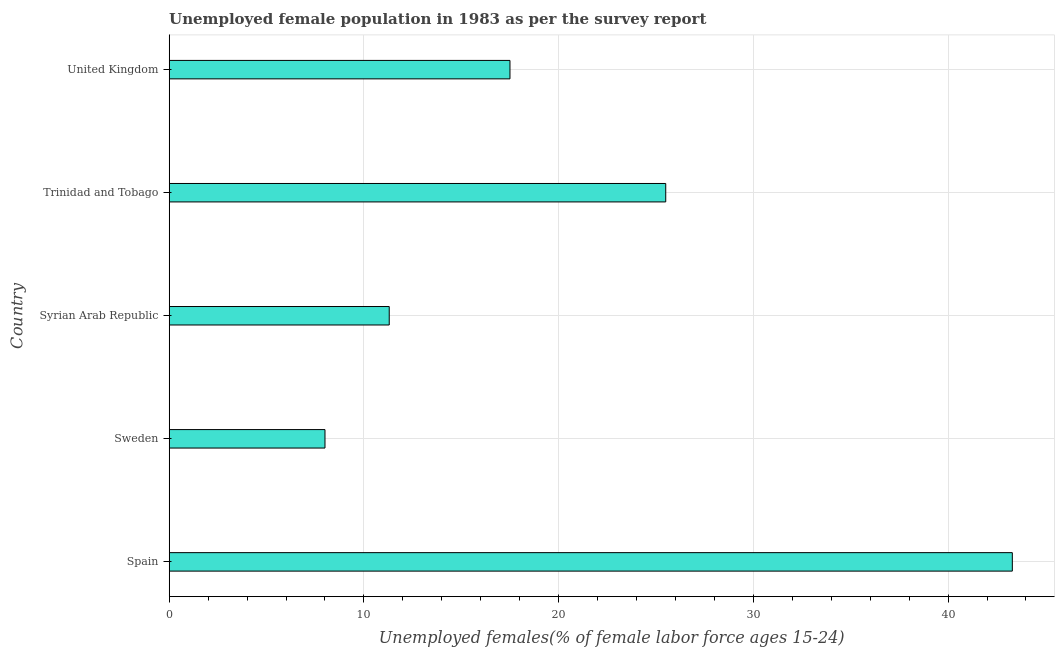Does the graph contain grids?
Keep it short and to the point. Yes. What is the title of the graph?
Give a very brief answer. Unemployed female population in 1983 as per the survey report. What is the label or title of the X-axis?
Offer a terse response. Unemployed females(% of female labor force ages 15-24). What is the label or title of the Y-axis?
Keep it short and to the point. Country. What is the unemployed female youth in Sweden?
Offer a terse response. 8. Across all countries, what is the maximum unemployed female youth?
Your answer should be compact. 43.3. Across all countries, what is the minimum unemployed female youth?
Give a very brief answer. 8. What is the sum of the unemployed female youth?
Provide a succinct answer. 105.6. What is the difference between the unemployed female youth in Spain and United Kingdom?
Offer a very short reply. 25.8. What is the average unemployed female youth per country?
Keep it short and to the point. 21.12. In how many countries, is the unemployed female youth greater than 26 %?
Offer a terse response. 1. What is the ratio of the unemployed female youth in Trinidad and Tobago to that in United Kingdom?
Offer a terse response. 1.46. Is the unemployed female youth in Spain less than that in Sweden?
Keep it short and to the point. No. Is the difference between the unemployed female youth in Syrian Arab Republic and Trinidad and Tobago greater than the difference between any two countries?
Give a very brief answer. No. Is the sum of the unemployed female youth in Trinidad and Tobago and United Kingdom greater than the maximum unemployed female youth across all countries?
Offer a very short reply. No. What is the difference between the highest and the lowest unemployed female youth?
Offer a very short reply. 35.3. How many bars are there?
Offer a terse response. 5. Are all the bars in the graph horizontal?
Your answer should be compact. Yes. How many countries are there in the graph?
Give a very brief answer. 5. Are the values on the major ticks of X-axis written in scientific E-notation?
Offer a very short reply. No. What is the Unemployed females(% of female labor force ages 15-24) of Spain?
Your answer should be very brief. 43.3. What is the Unemployed females(% of female labor force ages 15-24) in Sweden?
Your answer should be very brief. 8. What is the Unemployed females(% of female labor force ages 15-24) in Syrian Arab Republic?
Give a very brief answer. 11.3. What is the Unemployed females(% of female labor force ages 15-24) in Trinidad and Tobago?
Your answer should be very brief. 25.5. What is the Unemployed females(% of female labor force ages 15-24) in United Kingdom?
Give a very brief answer. 17.5. What is the difference between the Unemployed females(% of female labor force ages 15-24) in Spain and Sweden?
Keep it short and to the point. 35.3. What is the difference between the Unemployed females(% of female labor force ages 15-24) in Spain and Syrian Arab Republic?
Give a very brief answer. 32. What is the difference between the Unemployed females(% of female labor force ages 15-24) in Spain and United Kingdom?
Give a very brief answer. 25.8. What is the difference between the Unemployed females(% of female labor force ages 15-24) in Sweden and Trinidad and Tobago?
Provide a short and direct response. -17.5. What is the difference between the Unemployed females(% of female labor force ages 15-24) in Sweden and United Kingdom?
Ensure brevity in your answer.  -9.5. What is the difference between the Unemployed females(% of female labor force ages 15-24) in Syrian Arab Republic and United Kingdom?
Your answer should be compact. -6.2. What is the difference between the Unemployed females(% of female labor force ages 15-24) in Trinidad and Tobago and United Kingdom?
Offer a terse response. 8. What is the ratio of the Unemployed females(% of female labor force ages 15-24) in Spain to that in Sweden?
Make the answer very short. 5.41. What is the ratio of the Unemployed females(% of female labor force ages 15-24) in Spain to that in Syrian Arab Republic?
Provide a short and direct response. 3.83. What is the ratio of the Unemployed females(% of female labor force ages 15-24) in Spain to that in Trinidad and Tobago?
Provide a short and direct response. 1.7. What is the ratio of the Unemployed females(% of female labor force ages 15-24) in Spain to that in United Kingdom?
Offer a terse response. 2.47. What is the ratio of the Unemployed females(% of female labor force ages 15-24) in Sweden to that in Syrian Arab Republic?
Offer a terse response. 0.71. What is the ratio of the Unemployed females(% of female labor force ages 15-24) in Sweden to that in Trinidad and Tobago?
Your answer should be very brief. 0.31. What is the ratio of the Unemployed females(% of female labor force ages 15-24) in Sweden to that in United Kingdom?
Offer a very short reply. 0.46. What is the ratio of the Unemployed females(% of female labor force ages 15-24) in Syrian Arab Republic to that in Trinidad and Tobago?
Provide a short and direct response. 0.44. What is the ratio of the Unemployed females(% of female labor force ages 15-24) in Syrian Arab Republic to that in United Kingdom?
Make the answer very short. 0.65. What is the ratio of the Unemployed females(% of female labor force ages 15-24) in Trinidad and Tobago to that in United Kingdom?
Offer a very short reply. 1.46. 